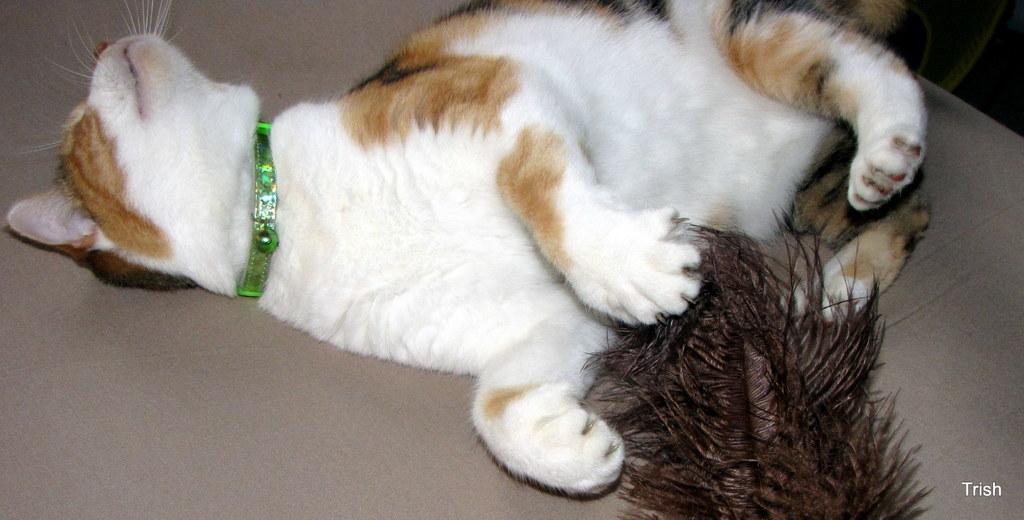Please provide a concise description of this image. In this image there is a cat and a feather on the object. 